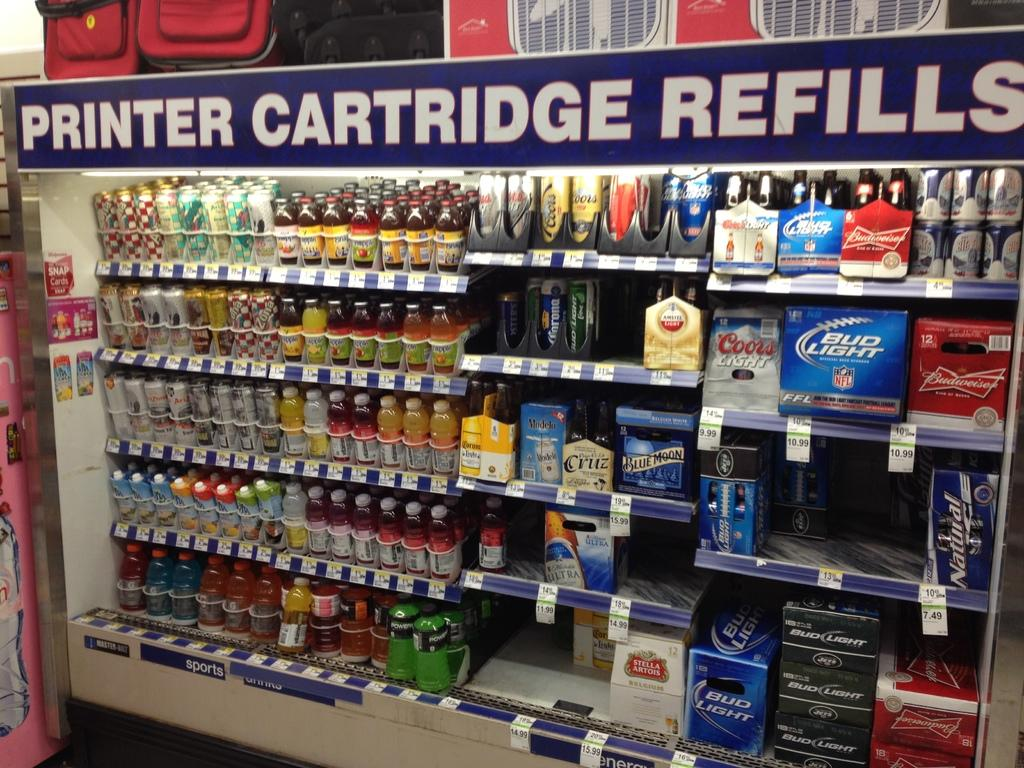<image>
Render a clear and concise summary of the photo. An cooler aisle in a store says Printer Cartridge Refills and has beverages in it. 